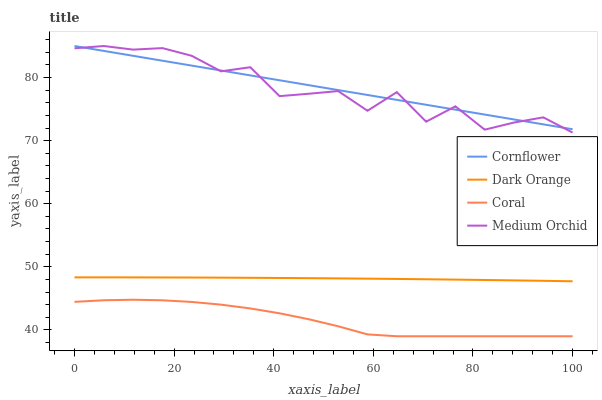Does Coral have the minimum area under the curve?
Answer yes or no. Yes. Does Cornflower have the maximum area under the curve?
Answer yes or no. Yes. Does Medium Orchid have the minimum area under the curve?
Answer yes or no. No. Does Medium Orchid have the maximum area under the curve?
Answer yes or no. No. Is Cornflower the smoothest?
Answer yes or no. Yes. Is Medium Orchid the roughest?
Answer yes or no. Yes. Is Coral the smoothest?
Answer yes or no. No. Is Coral the roughest?
Answer yes or no. No. Does Coral have the lowest value?
Answer yes or no. Yes. Does Medium Orchid have the lowest value?
Answer yes or no. No. Does Medium Orchid have the highest value?
Answer yes or no. Yes. Does Coral have the highest value?
Answer yes or no. No. Is Coral less than Cornflower?
Answer yes or no. Yes. Is Cornflower greater than Coral?
Answer yes or no. Yes. Does Cornflower intersect Medium Orchid?
Answer yes or no. Yes. Is Cornflower less than Medium Orchid?
Answer yes or no. No. Is Cornflower greater than Medium Orchid?
Answer yes or no. No. Does Coral intersect Cornflower?
Answer yes or no. No. 